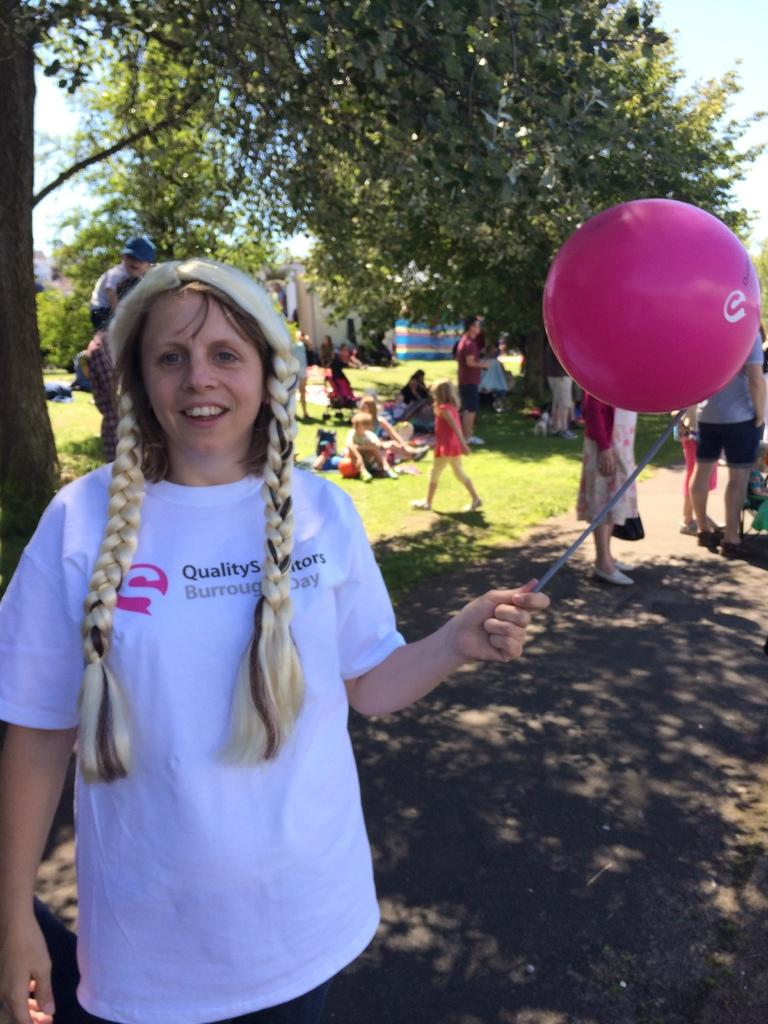What is the woman in the image holding? The woman is holding a stick. What is the woman's facial expression in the image? The woman is smiling. What can be seen in the background of the image? There are people, trees, grass, a walkway, objects, and the sky visible in the background of the image. What is the additional object present in the image? There is a balloon in the image. What type of exchange is taking place between the woman and the people in the background? There is no indication of an exchange taking place between the woman and the people in the background in the image. Is there a cellar visible in the image? There is no cellar present in the image. 